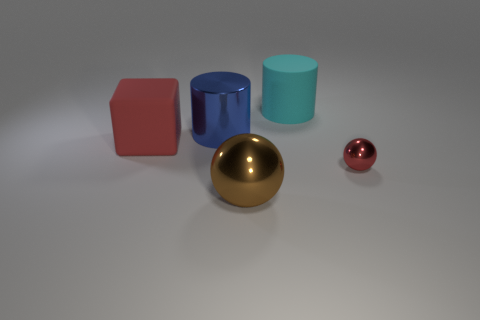Add 1 cyan matte cylinders. How many objects exist? 6 Subtract all balls. How many objects are left? 3 Add 1 big blue shiny cylinders. How many big blue shiny cylinders exist? 2 Subtract 0 yellow cubes. How many objects are left? 5 Subtract all gray balls. Subtract all red cubes. How many balls are left? 2 Subtract all yellow cylinders. Subtract all large brown metallic objects. How many objects are left? 4 Add 4 big rubber cylinders. How many big rubber cylinders are left? 5 